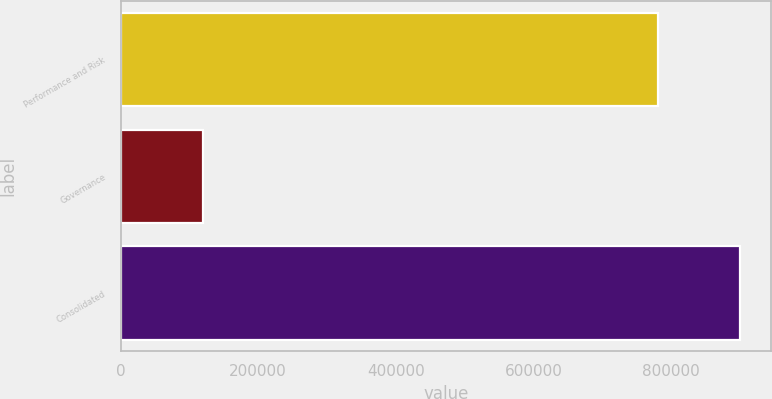Convert chart to OTSL. <chart><loc_0><loc_0><loc_500><loc_500><bar_chart><fcel>Performance and Risk<fcel>Governance<fcel>Consolidated<nl><fcel>781355<fcel>119586<fcel>900941<nl></chart> 